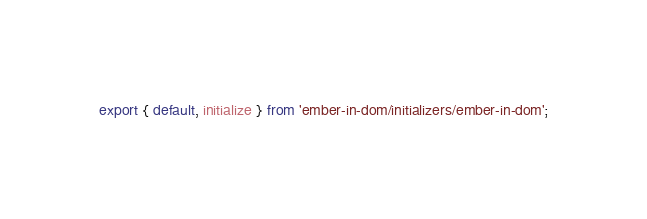Convert code to text. <code><loc_0><loc_0><loc_500><loc_500><_JavaScript_>export { default, initialize } from 'ember-in-dom/initializers/ember-in-dom';
</code> 